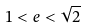Convert formula to latex. <formula><loc_0><loc_0><loc_500><loc_500>1 < e < \sqrt { 2 }</formula> 